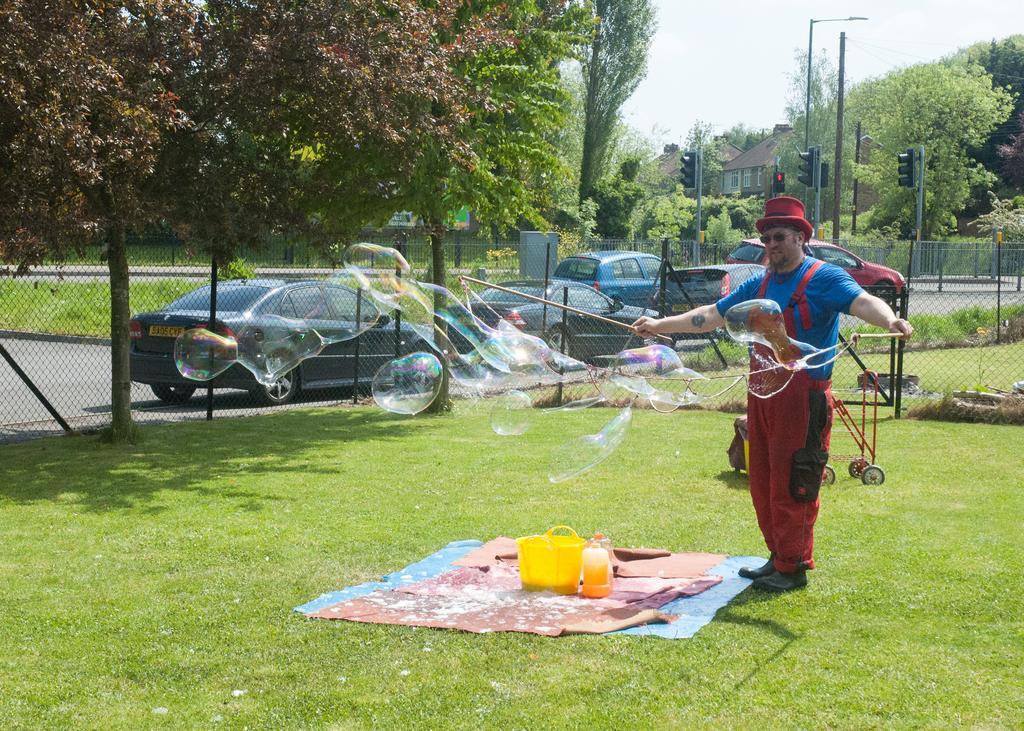Please provide a concise description of this image. In this picture we can see a man, he is standing on the grass, in front of him we can find few bottles and a tub, and he wore a red color hat, in the background we can find cars, trees, traffic lights, poles and houses, beside to him we can see fence. 